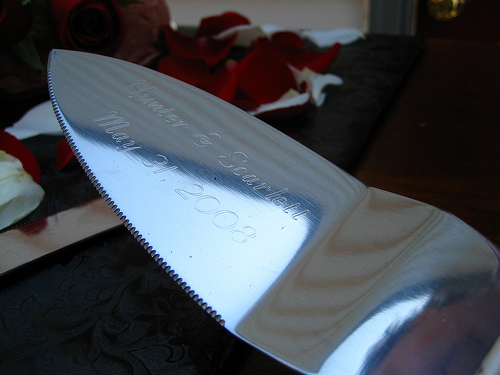<image>
Is there a numbers next to the cake knife? No. The numbers is not positioned next to the cake knife. They are located in different areas of the scene. 